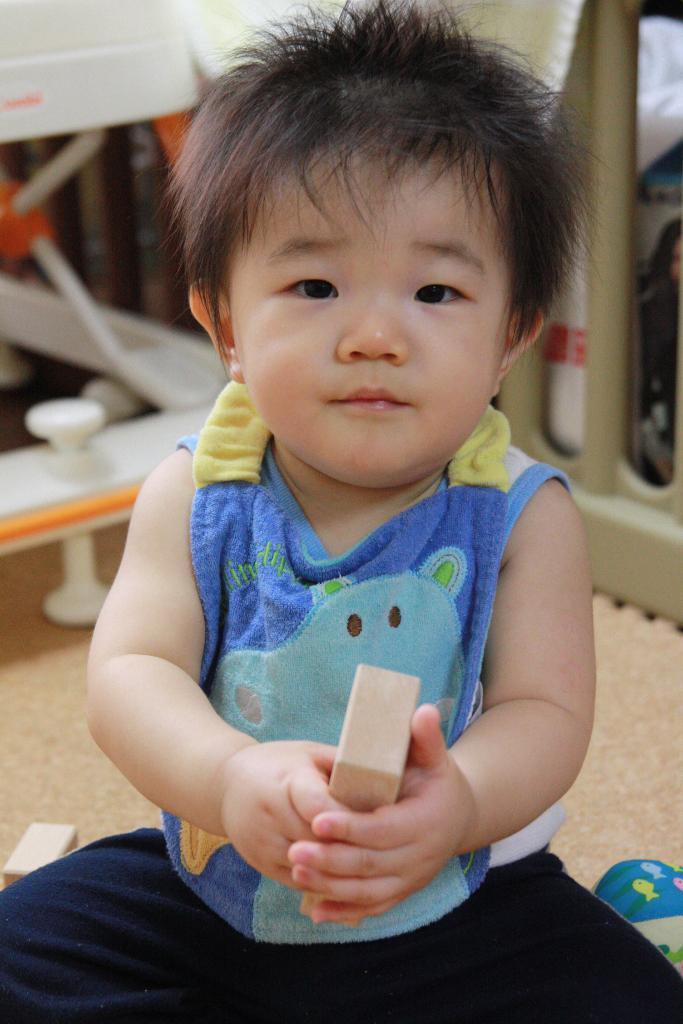How would you summarize this image in a sentence or two? In the image there is a baby with blue vest and black pant sitting on floor and holding a wooden block and behind the baby, it seems to be a baby cradle, 